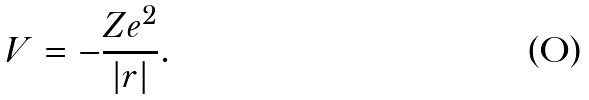Convert formula to latex. <formula><loc_0><loc_0><loc_500><loc_500>V = - \frac { Z e ^ { 2 } } { | { r | } } .</formula> 